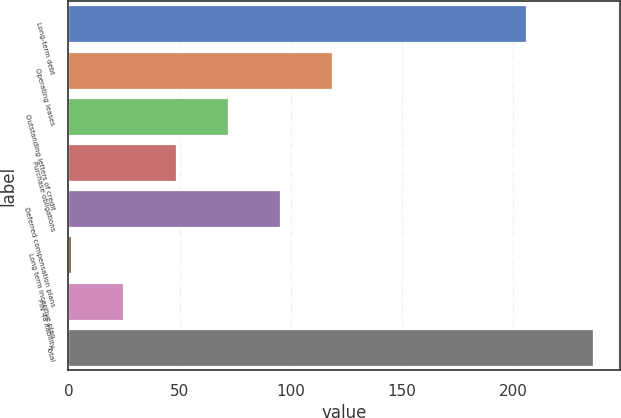Convert chart to OTSL. <chart><loc_0><loc_0><loc_500><loc_500><bar_chart><fcel>Long-term debt<fcel>Operating leases<fcel>Outstanding letters of credit<fcel>Purchase obligations<fcel>Deferred compensation plans<fcel>Long term incentive plan<fcel>FIN 48 liability<fcel>Total<nl><fcel>205.5<fcel>118.65<fcel>71.71<fcel>48.24<fcel>95.18<fcel>1.3<fcel>24.77<fcel>236<nl></chart> 